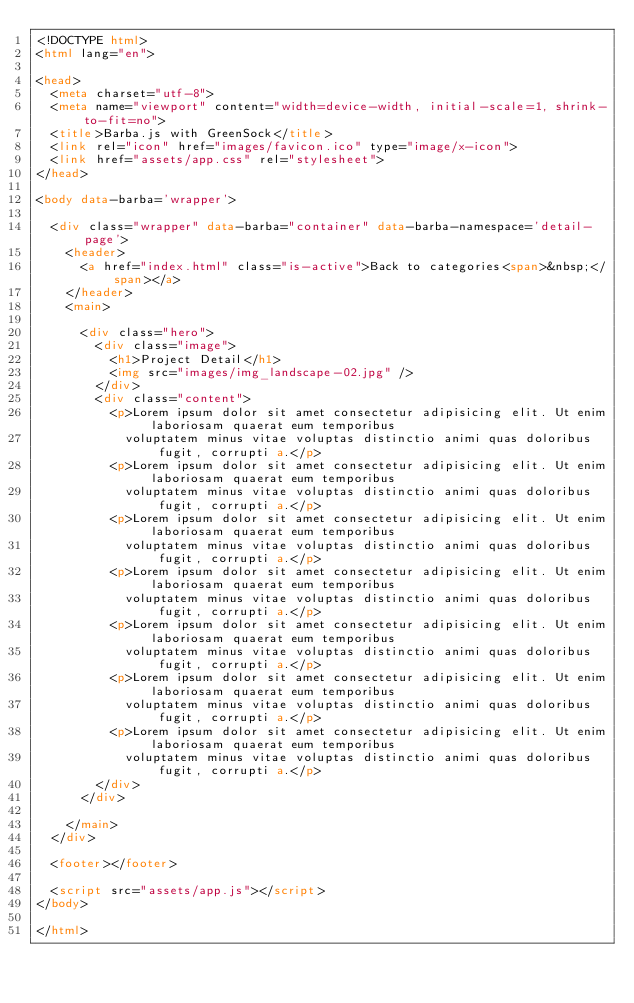Convert code to text. <code><loc_0><loc_0><loc_500><loc_500><_HTML_><!DOCTYPE html>
<html lang="en">

<head>
  <meta charset="utf-8">
  <meta name="viewport" content="width=device-width, initial-scale=1, shrink-to-fit=no">
  <title>Barba.js with GreenSock</title>
  <link rel="icon" href="images/favicon.ico" type="image/x-icon">
  <link href="assets/app.css" rel="stylesheet">
</head>

<body data-barba='wrapper'>

  <div class="wrapper" data-barba="container" data-barba-namespace='detail-page'>
    <header>
      <a href="index.html" class="is-active">Back to categories<span>&nbsp;</span></a>
    </header>
    <main>

      <div class="hero">
        <div class="image">
          <h1>Project Detail</h1>
          <img src="images/img_landscape-02.jpg" />
        </div>
        <div class="content">
          <p>Lorem ipsum dolor sit amet consectetur adipisicing elit. Ut enim laboriosam quaerat eum temporibus
            voluptatem minus vitae voluptas distinctio animi quas doloribus fugit, corrupti a.</p>
          <p>Lorem ipsum dolor sit amet consectetur adipisicing elit. Ut enim laboriosam quaerat eum temporibus
            voluptatem minus vitae voluptas distinctio animi quas doloribus fugit, corrupti a.</p>
          <p>Lorem ipsum dolor sit amet consectetur adipisicing elit. Ut enim laboriosam quaerat eum temporibus
            voluptatem minus vitae voluptas distinctio animi quas doloribus fugit, corrupti a.</p>
          <p>Lorem ipsum dolor sit amet consectetur adipisicing elit. Ut enim laboriosam quaerat eum temporibus
            voluptatem minus vitae voluptas distinctio animi quas doloribus fugit, corrupti a.</p>
          <p>Lorem ipsum dolor sit amet consectetur adipisicing elit. Ut enim laboriosam quaerat eum temporibus
            voluptatem minus vitae voluptas distinctio animi quas doloribus fugit, corrupti a.</p>
          <p>Lorem ipsum dolor sit amet consectetur adipisicing elit. Ut enim laboriosam quaerat eum temporibus
            voluptatem minus vitae voluptas distinctio animi quas doloribus fugit, corrupti a.</p>
          <p>Lorem ipsum dolor sit amet consectetur adipisicing elit. Ut enim laboriosam quaerat eum temporibus
            voluptatem minus vitae voluptas distinctio animi quas doloribus fugit, corrupti a.</p>
        </div>
      </div>

    </main>
  </div>

  <footer></footer>

  <script src="assets/app.js"></script>
</body>

</html></code> 